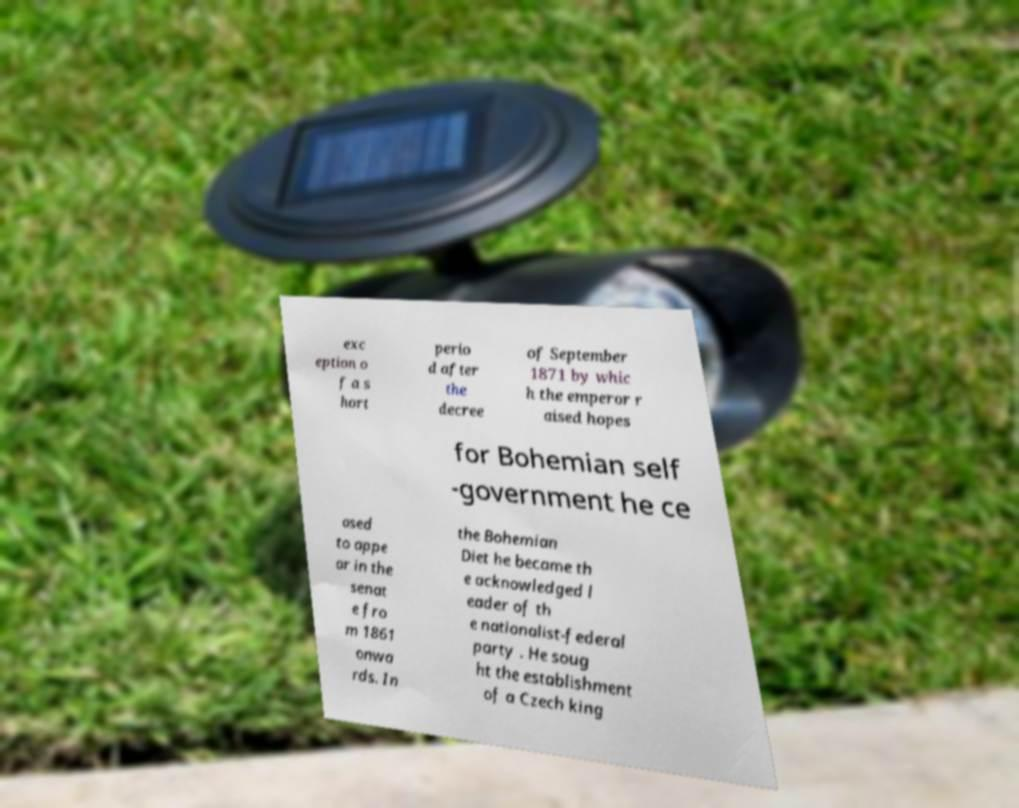Can you accurately transcribe the text from the provided image for me? exc eption o f a s hort perio d after the decree of September 1871 by whic h the emperor r aised hopes for Bohemian self -government he ce ased to appe ar in the senat e fro m 1861 onwa rds. In the Bohemian Diet he became th e acknowledged l eader of th e nationalist-federal party . He soug ht the establishment of a Czech king 